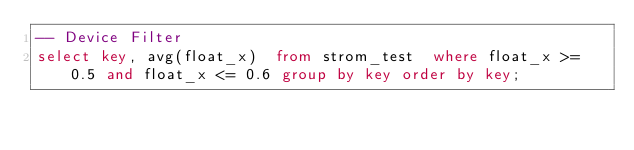Convert code to text. <code><loc_0><loc_0><loc_500><loc_500><_SQL_>-- Device Filter
select key, avg(float_x)  from strom_test  where float_x >= 0.5 and float_x <= 0.6 group by key order by key;
</code> 